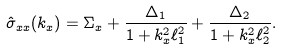<formula> <loc_0><loc_0><loc_500><loc_500>\hat { \sigma } _ { x x } ( k _ { x } ) = \Sigma _ { x } + \frac { \Delta _ { 1 } } { 1 + k _ { x } ^ { 2 } \ell _ { 1 } ^ { 2 } } + \frac { \Delta _ { 2 } } { 1 + k _ { x } ^ { 2 } \ell _ { 2 } ^ { 2 } } .</formula> 